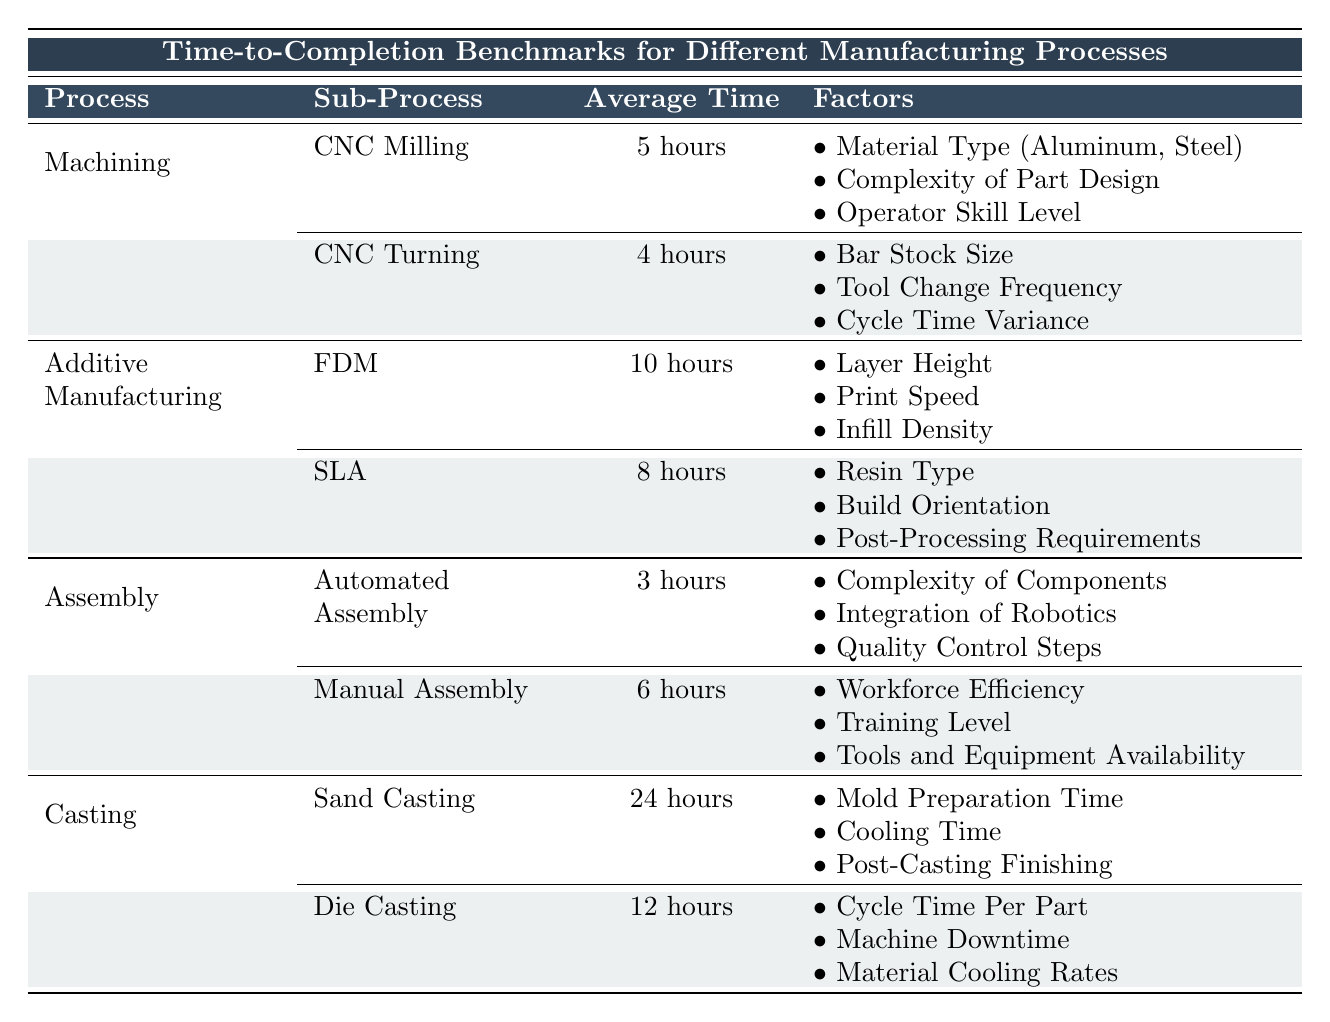What is the average time to complete CNC Turning? The table indicates that the average time for CNC Turning is 4 hours, which is directly stated in the corresponding row under "Machining".
Answer: 4 hours Which manufacturing process takes the longest time to complete? By reviewing the "Average Time" values across all manufacturing processes, Sand Casting shows the longest average time of 24 hours, as listed in the "Casting" section.
Answer: Sand Casting Is the average time for Automated Assembly less than that for Manual Assembly? The average time for Automated Assembly is 3 hours, whereas Manual Assembly takes 6 hours. Since 3 hours is less than 6 hours, the statement is true.
Answer: Yes What is the total average time for all processes under Additive Manufacturing? To find the total average time for Additive Manufacturing, sum the average times of FDM (10 hours) and SLA (8 hours), resulting in 10 + 8 = 18 hours.
Answer: 18 hours Are there any factors that affect the time to completion of CNC Milling? The table lists three factors affecting CNC Milling: Material Type, Complexity of Part Design, and Operator Skill Level, confirming that there are indeed factors involved.
Answer: Yes Which process has the shortest average completion time and what is it? The shortest average completion time is for Automated Assembly, which takes 3 hours according to the data provided in the "Assembly" section.
Answer: Automated Assembly, 3 hours How many factors affect the time to completion of Die Casting? The table shows that Die Casting has three influencing factors: Cycle Time Per Part, Machine Downtime, and Material Cooling Rates, confirming that there are 3 factors.
Answer: 3 factors What is the difference in average time between CNC Milling and CNC Turning? CNC Milling has an average time of 5 hours, and CNC Turning has an average time of 4 hours. The difference is calculated as 5 - 4 = 1 hour.
Answer: 1 hour Is the average time to complete Fused Deposition Modeling greater than 9 hours? The average time for Fused Deposition Modeling is listed as 10 hours, which is indeed greater than 9 hours, making the statement true.
Answer: Yes 